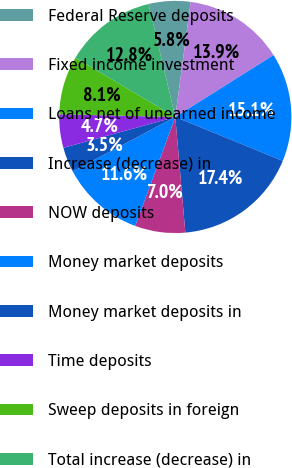Convert chart to OTSL. <chart><loc_0><loc_0><loc_500><loc_500><pie_chart><fcel>Federal Reserve deposits<fcel>Fixed income investment<fcel>Loans net of unearned income<fcel>Increase (decrease) in<fcel>NOW deposits<fcel>Money market deposits<fcel>Money market deposits in<fcel>Time deposits<fcel>Sweep deposits in foreign<fcel>Total increase (decrease) in<nl><fcel>5.81%<fcel>13.95%<fcel>15.12%<fcel>17.44%<fcel>6.98%<fcel>11.63%<fcel>3.49%<fcel>4.65%<fcel>8.14%<fcel>12.79%<nl></chart> 